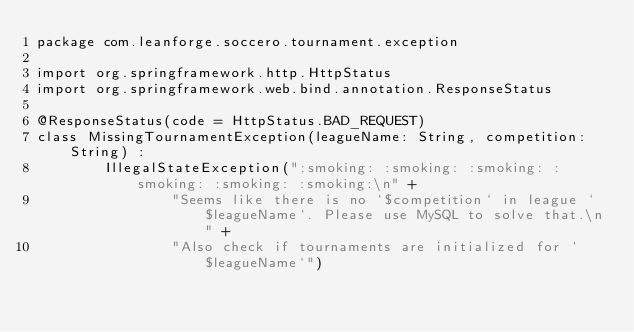<code> <loc_0><loc_0><loc_500><loc_500><_Kotlin_>package com.leanforge.soccero.tournament.exception

import org.springframework.http.HttpStatus
import org.springframework.web.bind.annotation.ResponseStatus

@ResponseStatus(code = HttpStatus.BAD_REQUEST)
class MissingTournamentException(leagueName: String, competition: String) :
        IllegalStateException(":smoking: :smoking: :smoking: :smoking: :smoking: :smoking:\n" +
                "Seems like there is no `$competition` in league `$leagueName`. Please use MySQL to solve that.\n" +
                "Also check if tournaments are initialized for `$leagueName`")</code> 